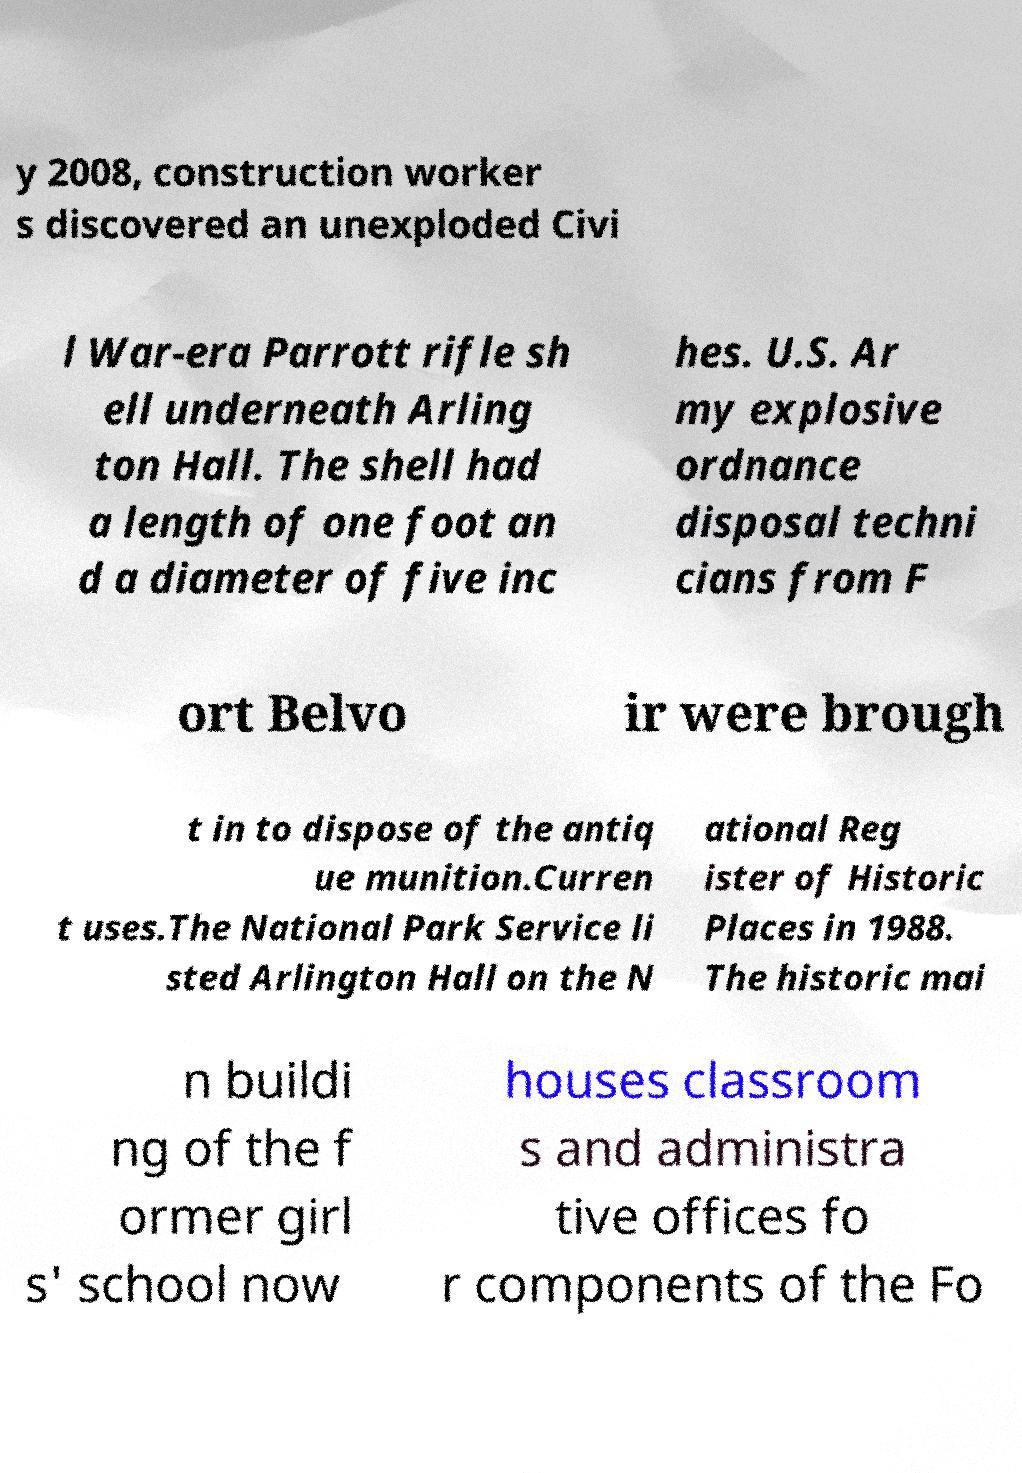Please read and relay the text visible in this image. What does it say? y 2008, construction worker s discovered an unexploded Civi l War-era Parrott rifle sh ell underneath Arling ton Hall. The shell had a length of one foot an d a diameter of five inc hes. U.S. Ar my explosive ordnance disposal techni cians from F ort Belvo ir were brough t in to dispose of the antiq ue munition.Curren t uses.The National Park Service li sted Arlington Hall on the N ational Reg ister of Historic Places in 1988. The historic mai n buildi ng of the f ormer girl s' school now houses classroom s and administra tive offices fo r components of the Fo 